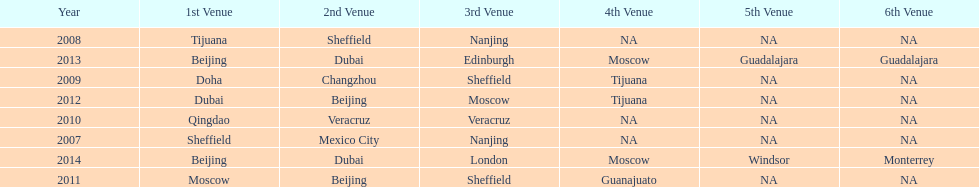What years had the most venues? 2013, 2014. 